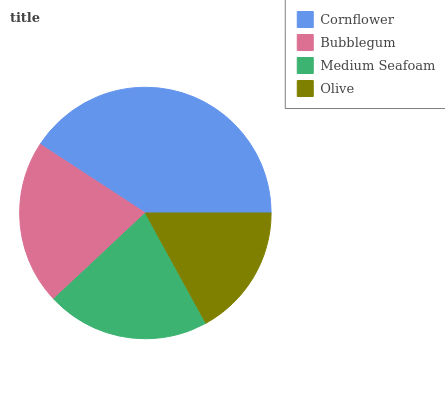Is Olive the minimum?
Answer yes or no. Yes. Is Cornflower the maximum?
Answer yes or no. Yes. Is Bubblegum the minimum?
Answer yes or no. No. Is Bubblegum the maximum?
Answer yes or no. No. Is Cornflower greater than Bubblegum?
Answer yes or no. Yes. Is Bubblegum less than Cornflower?
Answer yes or no. Yes. Is Bubblegum greater than Cornflower?
Answer yes or no. No. Is Cornflower less than Bubblegum?
Answer yes or no. No. Is Bubblegum the high median?
Answer yes or no. Yes. Is Medium Seafoam the low median?
Answer yes or no. Yes. Is Cornflower the high median?
Answer yes or no. No. Is Bubblegum the low median?
Answer yes or no. No. 